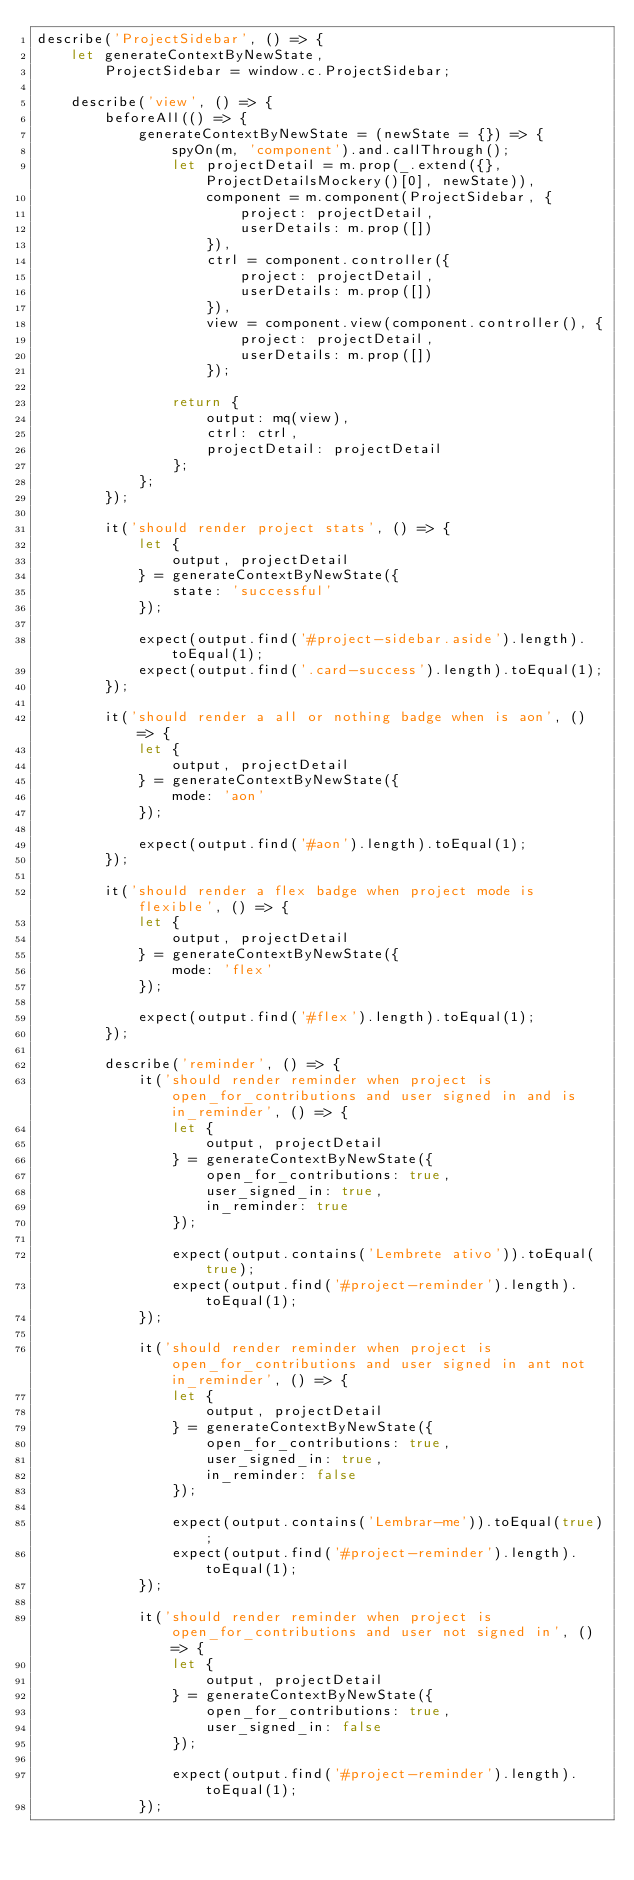Convert code to text. <code><loc_0><loc_0><loc_500><loc_500><_JavaScript_>describe('ProjectSidebar', () => {
    let generateContextByNewState,
        ProjectSidebar = window.c.ProjectSidebar;

    describe('view', () => {
        beforeAll(() => {
            generateContextByNewState = (newState = {}) => {
                spyOn(m, 'component').and.callThrough();
                let projectDetail = m.prop(_.extend({}, ProjectDetailsMockery()[0], newState)),
                    component = m.component(ProjectSidebar, {
                        project: projectDetail,
                        userDetails: m.prop([])
                    }),
                    ctrl = component.controller({
                        project: projectDetail,
                        userDetails: m.prop([])
                    }),
                    view = component.view(component.controller(), {
                        project: projectDetail,
                        userDetails: m.prop([])
                    });

                return {
                    output: mq(view),
                    ctrl: ctrl,
                    projectDetail: projectDetail
                };
            };
        });

        it('should render project stats', () => {
            let {
                output, projectDetail
            } = generateContextByNewState({
                state: 'successful'
            });

            expect(output.find('#project-sidebar.aside').length).toEqual(1);
            expect(output.find('.card-success').length).toEqual(1);
        });

        it('should render a all or nothing badge when is aon', () => {
            let {
                output, projectDetail
            } = generateContextByNewState({
                mode: 'aon'
            });

            expect(output.find('#aon').length).toEqual(1);
        });

        it('should render a flex badge when project mode is flexible', () => {
            let {
                output, projectDetail
            } = generateContextByNewState({
                mode: 'flex'
            });

            expect(output.find('#flex').length).toEqual(1);
        });

        describe('reminder', () => {
            it('should render reminder when project is open_for_contributions and user signed in and is in_reminder', () => {
                let {
                    output, projectDetail
                } = generateContextByNewState({
                    open_for_contributions: true,
                    user_signed_in: true,
                    in_reminder: true
                });

                expect(output.contains('Lembrete ativo')).toEqual(true);
                expect(output.find('#project-reminder').length).toEqual(1);
            });

            it('should render reminder when project is open_for_contributions and user signed in ant not in_reminder', () => {
                let {
                    output, projectDetail
                } = generateContextByNewState({
                    open_for_contributions: true,
                    user_signed_in: true,
                    in_reminder: false
                });

                expect(output.contains('Lembrar-me')).toEqual(true);
                expect(output.find('#project-reminder').length).toEqual(1);
            });

            it('should render reminder when project is open_for_contributions and user not signed in', () => {
                let {
                    output, projectDetail
                } = generateContextByNewState({
                    open_for_contributions: true,
                    user_signed_in: false
                });

                expect(output.find('#project-reminder').length).toEqual(1);
            });
</code> 